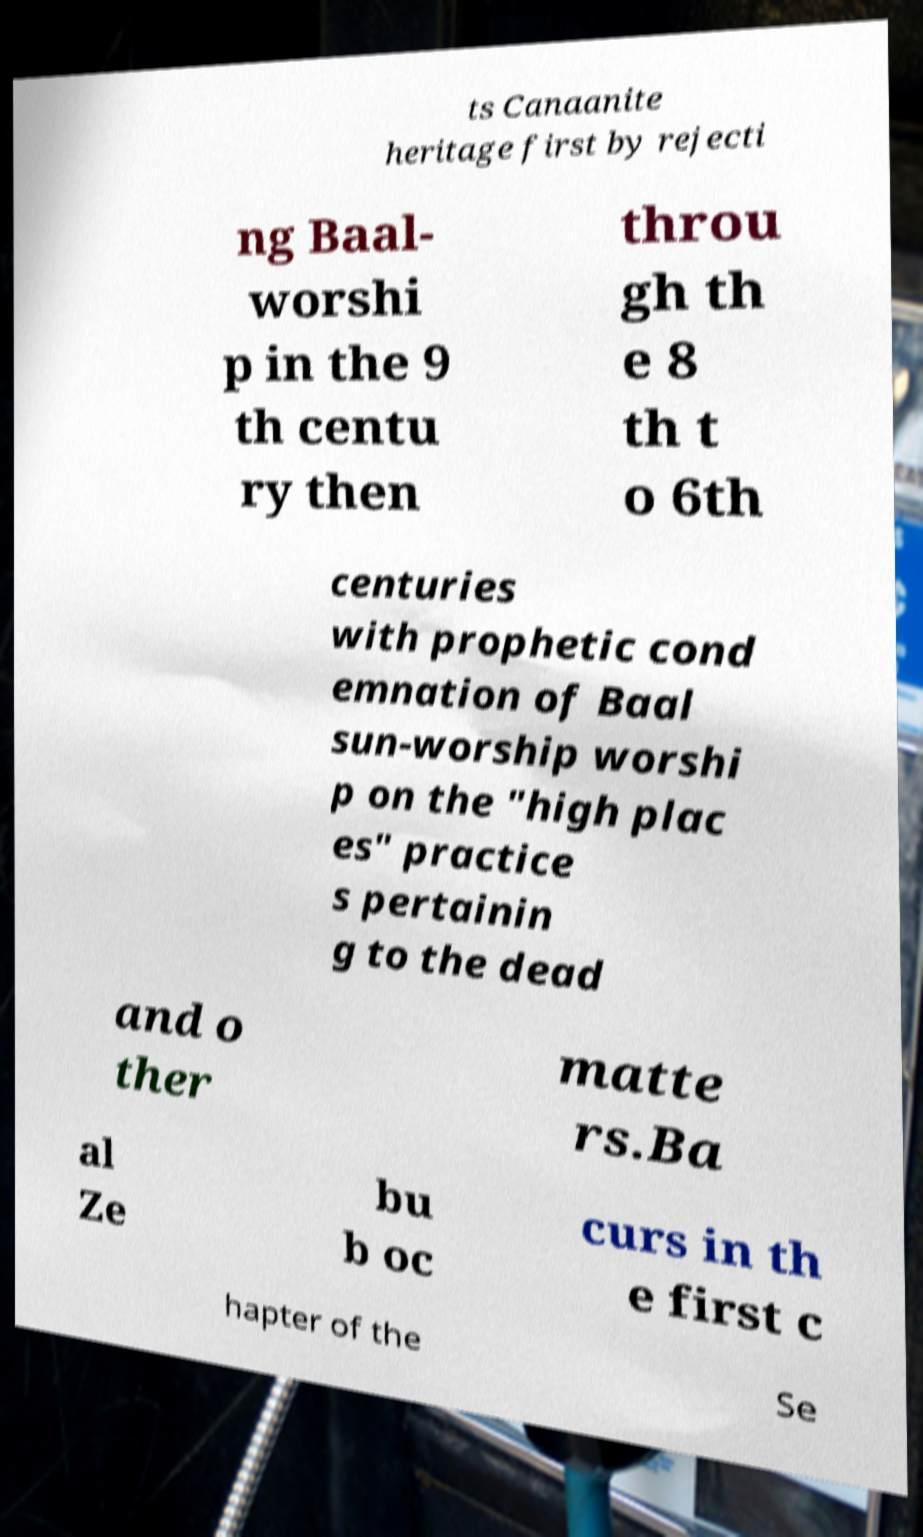There's text embedded in this image that I need extracted. Can you transcribe it verbatim? ts Canaanite heritage first by rejecti ng Baal- worshi p in the 9 th centu ry then throu gh th e 8 th t o 6th centuries with prophetic cond emnation of Baal sun-worship worshi p on the "high plac es" practice s pertainin g to the dead and o ther matte rs.Ba al Ze bu b oc curs in th e first c hapter of the Se 